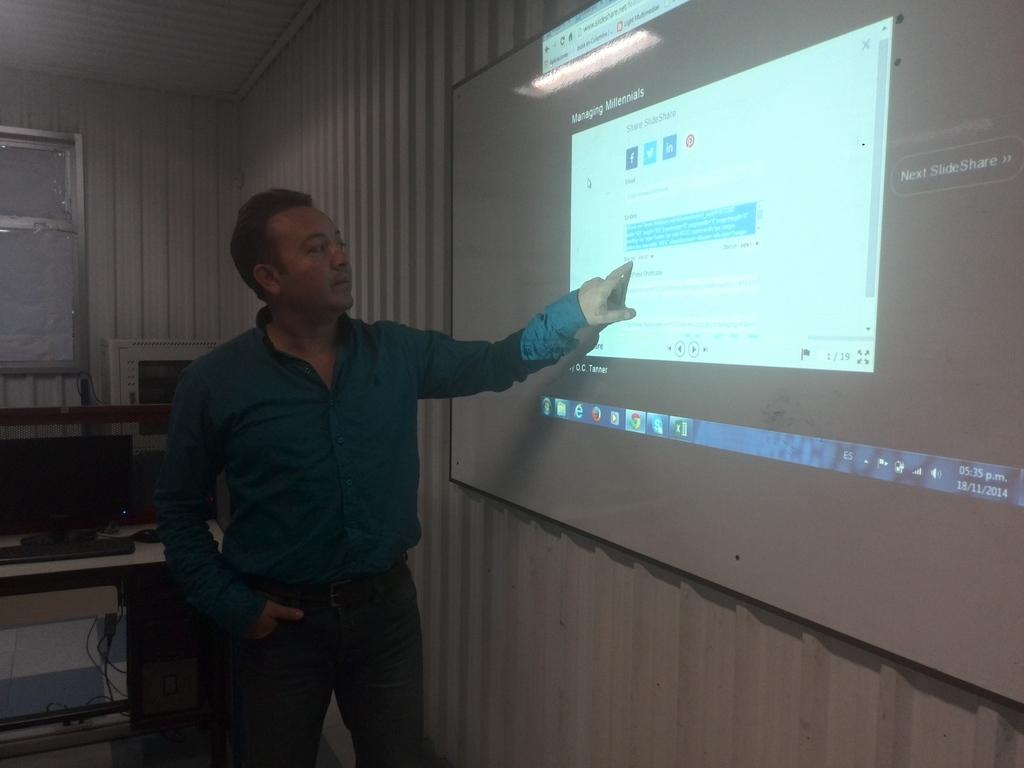What date is listed in the lower right corner of the screen?
Your response must be concise. 18/11/2014. 